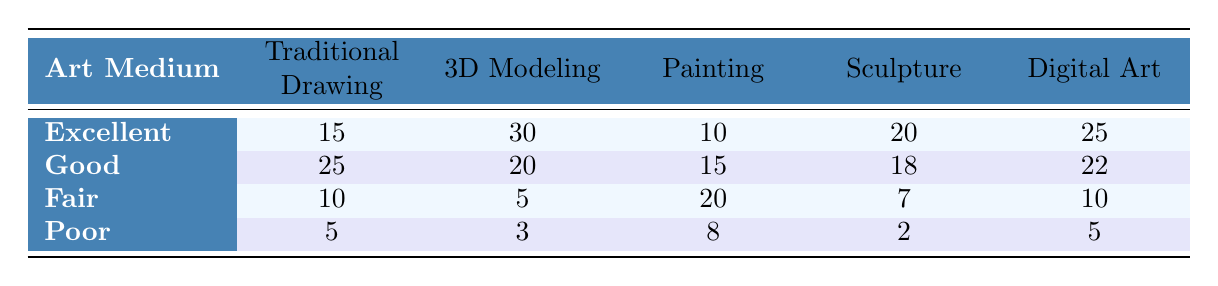What is the highest anatomical accuracy rating for Traditional Drawing? The highest rating for Traditional Drawing is "Excellent," which has a count of 15.
Answer: Excellent Which art medium has the lowest count for the "Poor" rating? The "Poor" rating count for Sculpture is 2, which is lower than the counts for all other mediums.
Answer: Sculpture What is the total count of "Good" ratings across all art mediums? The counts for "Good" ratings are: Traditional Drawing (25), 3D Modeling (20), Painting (15), Sculpture (18), and Digital Art (22). Summing these up gives 25 + 20 + 15 + 18 + 22 = 100.
Answer: 100 How many art mediums have an "Excellent" rating count greater than the "Fair" rating count? The art mediums with an "Excellent" rating count greater than the "Fair" count are: Traditional Drawing (15 > 10), 3D Modeling (30 > 5), Sculpture (20 > 7), and Digital Art (25 > 10). This gives us 4 mediums.
Answer: 4 Is it true that 3D Modeling has the highest count for " Excellent" anatomical accuracy ratings? Yes, 3D Modeling has a count of 30 for "Excellent," which is higher than any other medium in the table.
Answer: Yes What is the average count of the "Fair" rating across all art mediums? The "Fair" counts are: Traditional Drawing (10), 3D Modeling (5), Painting (20), Sculpture (7), and Digital Art (10). Summing these gives 10 + 5 + 20 + 7 + 10 = 52, and dividing by 5 gives 52 / 5 = 10.4.
Answer: 10.4 Which medium has a higher count for "Good" ratings, Digital Art or Sculpture? Digital Art has a count of 22 for "Good," while Sculpture has a count of 18. Comparing these two, Digital Art has the higher count.
Answer: Digital Art What is the total sum of anatomical accuracy ratings for Painting? The counts for Painting are: Excellent (10), Good (15), Fair (20), and Poor (8). Summing these gives 10 + 15 + 20 + 8 = 53.
Answer: 53 